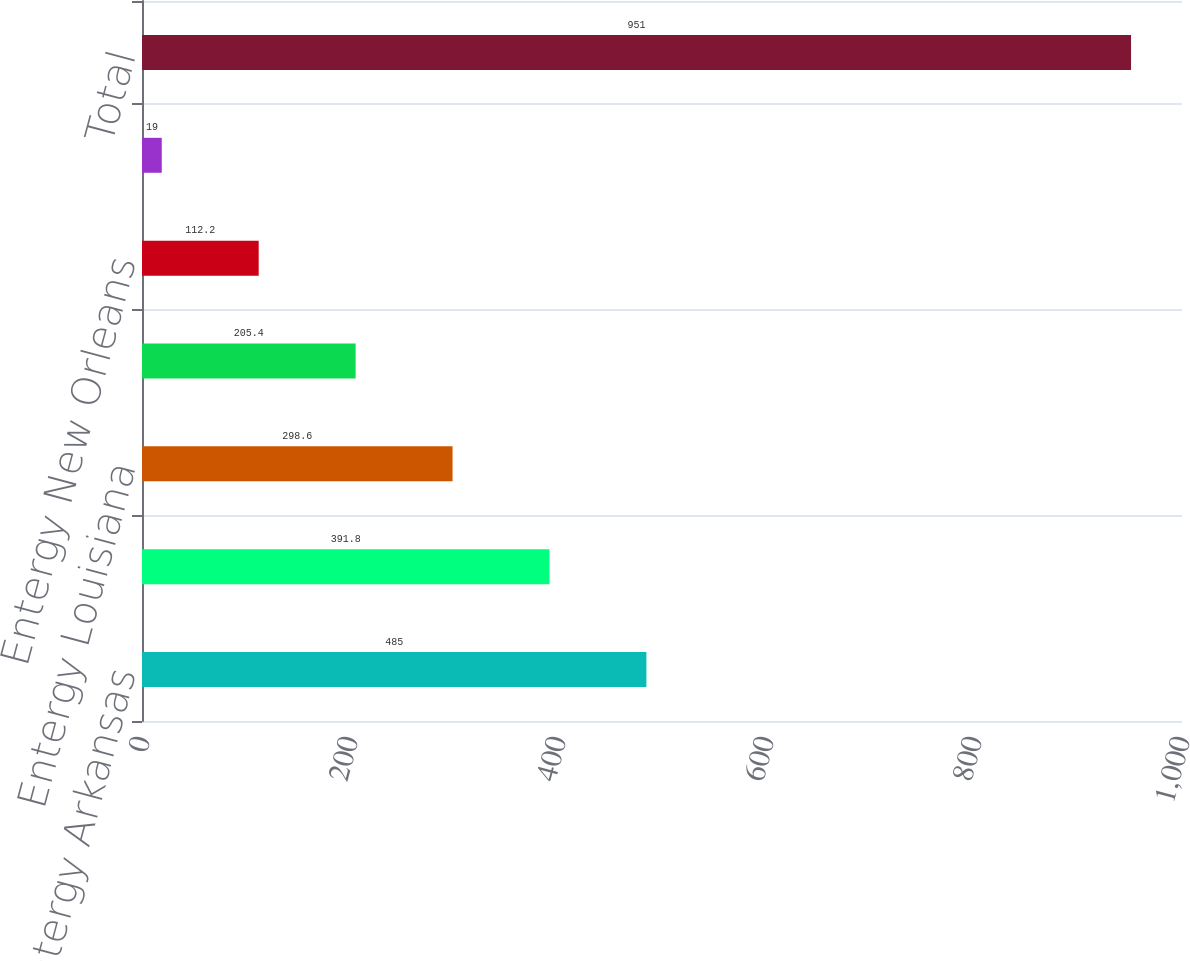Convert chart. <chart><loc_0><loc_0><loc_500><loc_500><bar_chart><fcel>Entergy Arkansas<fcel>Entergy Gulf States<fcel>Entergy Louisiana<fcel>Entergy Mississippi<fcel>Entergy New Orleans<fcel>System Energy<fcel>Total<nl><fcel>485<fcel>391.8<fcel>298.6<fcel>205.4<fcel>112.2<fcel>19<fcel>951<nl></chart> 